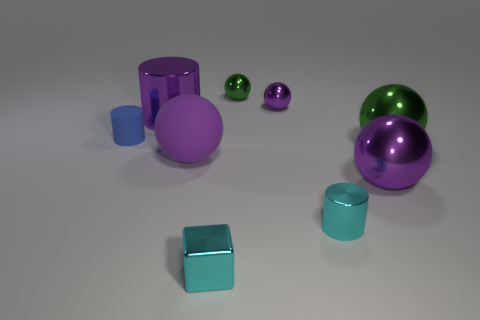Subtract all blue cubes. How many purple balls are left? 3 Subtract all purple cylinders. Subtract all green cubes. How many cylinders are left? 2 Add 1 tiny blue rubber objects. How many objects exist? 10 Subtract all cubes. How many objects are left? 8 Subtract all large things. Subtract all yellow cylinders. How many objects are left? 5 Add 1 small cyan metallic cylinders. How many small cyan metallic cylinders are left? 2 Add 7 brown things. How many brown things exist? 7 Subtract 0 yellow blocks. How many objects are left? 9 